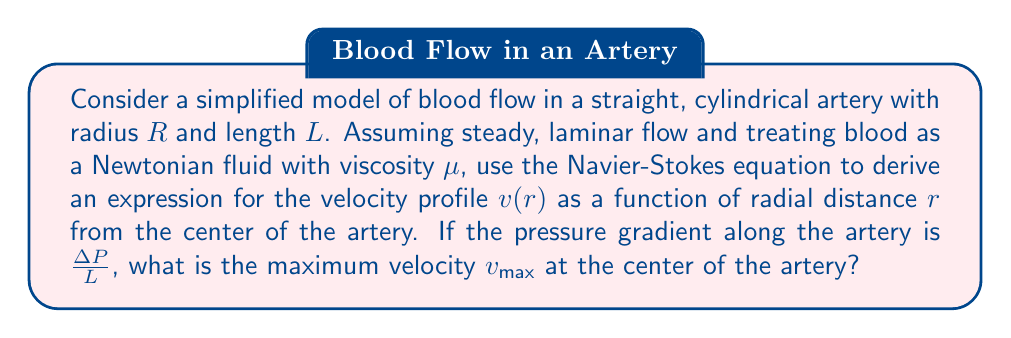Help me with this question. To solve this problem, we'll use the Navier-Stokes equation for incompressible, steady-state flow in cylindrical coordinates. Given the symmetry of the problem, we can assume that the velocity only depends on the radial coordinate $r$.

1) The Navier-Stokes equation in cylindrical coordinates for this case reduces to:

   $$\frac{1}{r}\frac{d}{dr}\left(r\frac{dv}{dr}\right) = \frac{1}{\mu}\frac{\Delta P}{L}$$

2) Integrate both sides with respect to $r$:

   $$r\frac{dv}{dr} = \frac{r^2}{2\mu}\frac{\Delta P}{L} + C_1$$

3) Divide by $r$ and integrate again:

   $$v(r) = \frac{r^2}{4\mu}\frac{\Delta P}{L} + C_1\ln(r) + C_2$$

4) Apply boundary conditions:
   - At $r = R$, $v(R) = 0$ (no-slip condition at the wall)
   - At $r = 0$, $v(r)$ must be finite (velocity at the center is finite)

5) The second condition implies $C_1 = 0$ (to avoid logarithmic singularity at $r=0$).

6) Using the first condition:

   $$0 = \frac{R^2}{4\mu}\frac{\Delta P}{L} + C_2$$

   $$C_2 = -\frac{R^2}{4\mu}\frac{\Delta P}{L}$$

7) Therefore, the velocity profile is:

   $$v(r) = \frac{\Delta P}{4\mu L}(R^2 - r^2)$$

8) The maximum velocity occurs at the center of the artery ($r = 0$):

   $$v_{max} = v(0) = \frac{\Delta P}{4\mu L}R^2$$

This parabolic velocity profile is known as Poiseuille flow, which is commonly used to model blood flow in larger arteries where blood can be approximated as a Newtonian fluid.
Answer: The maximum velocity at the center of the artery is:

$$v_{max} = \frac{\Delta P}{4\mu L}R^2$$

where $\Delta P$ is the pressure difference, $L$ is the length of the artery, $\mu$ is the blood viscosity, and $R$ is the radius of the artery. 